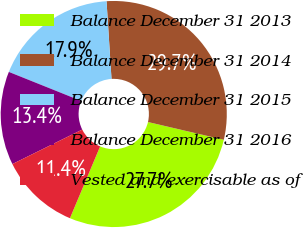<chart> <loc_0><loc_0><loc_500><loc_500><pie_chart><fcel>Balance December 31 2013<fcel>Balance December 31 2014<fcel>Balance December 31 2015<fcel>Balance December 31 2016<fcel>Vested and exercisable as of<nl><fcel>27.67%<fcel>29.68%<fcel>17.91%<fcel>13.37%<fcel>11.37%<nl></chart> 